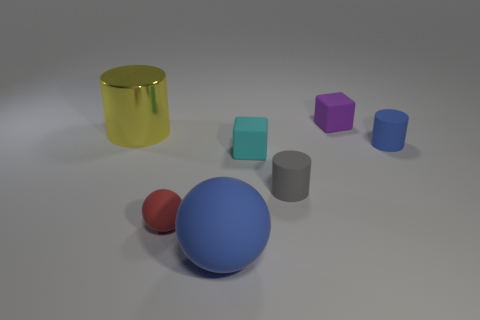Add 1 big blue balls. How many objects exist? 8 Subtract all blocks. How many objects are left? 5 Subtract all small shiny cylinders. Subtract all rubber things. How many objects are left? 1 Add 5 tiny gray matte cylinders. How many tiny gray matte cylinders are left? 6 Add 3 tiny rubber cylinders. How many tiny rubber cylinders exist? 5 Subtract 0 red cylinders. How many objects are left? 7 